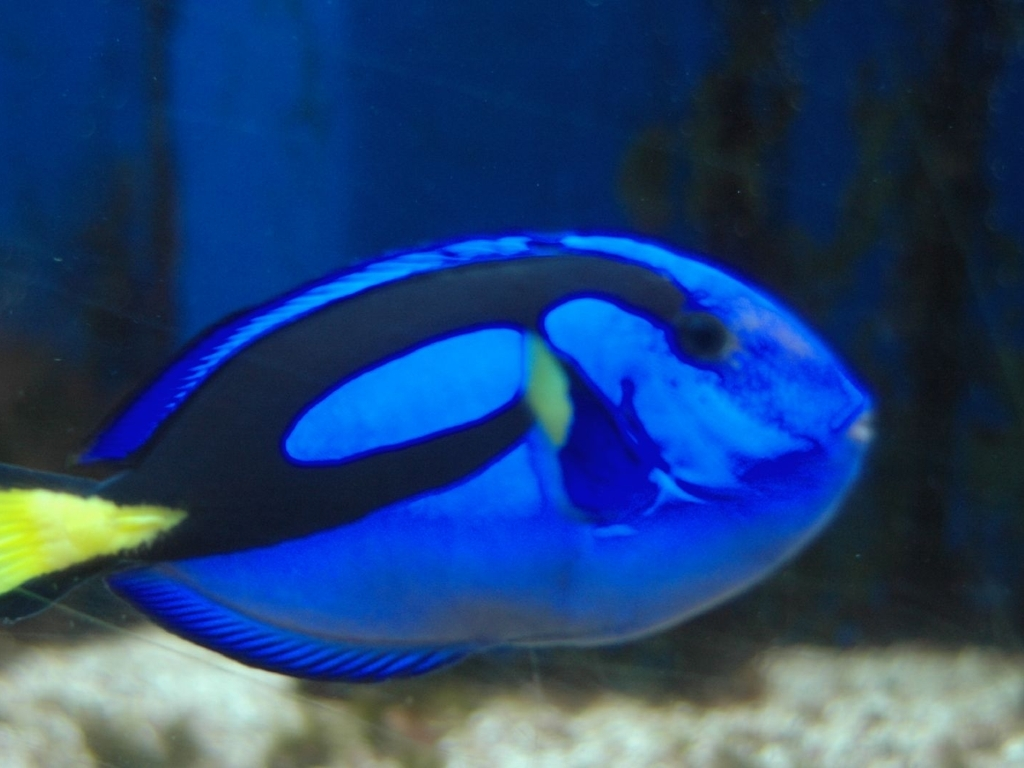Can you describe the ideal habitat for the fish seen in the image? The blue tang thrives in coral reefs, where it can be found in the warmer waters of the Indo-Pacific. It favors a habitat rich in coral and algae, providing both shelter and food sources in a vibrant and biodiverse ecosystem. 